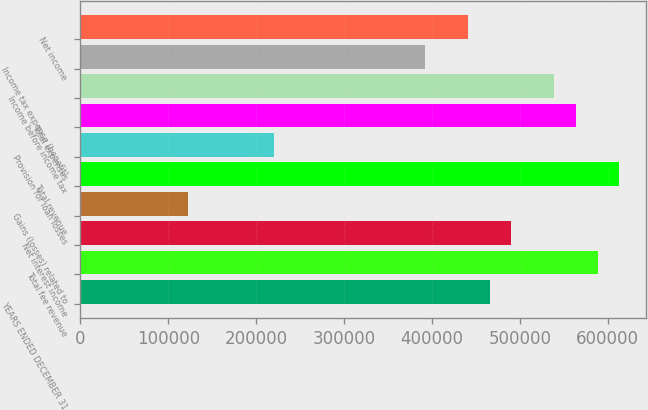<chart> <loc_0><loc_0><loc_500><loc_500><bar_chart><fcel>YEARS ENDED DECEMBER 31<fcel>Total fee revenue<fcel>Net interest income<fcel>Gains (losses) related to<fcel>Total revenue<fcel>Provision for loan losses<fcel>Total expenses<fcel>Income before income tax<fcel>Income tax expense (benefit)<fcel>Net income<nl><fcel>465794<fcel>588371<fcel>490309<fcel>122578<fcel>612886<fcel>220640<fcel>563855<fcel>539340<fcel>392248<fcel>441278<nl></chart> 